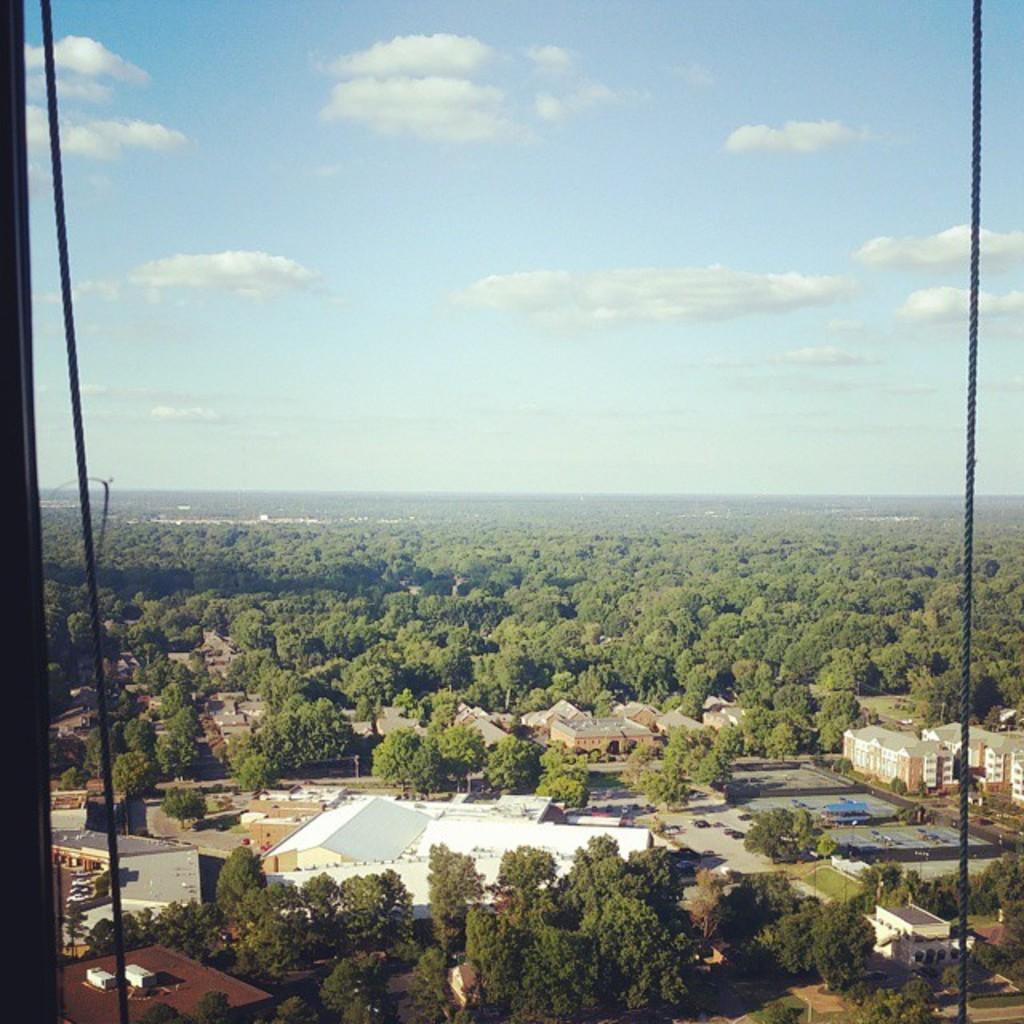What type of objects can be seen in the image? There are ropes, houses, trees, and other objects in the image. Can you describe the natural elements in the image? There are trees and clouds in the sky in the image. How many houses are visible in the image? There are houses in the image, but the exact number is not specified. What type of duck can be seen swimming in the river in the image? There is no river or duck present in the image. What type of fact can be learned from the image? The provided facts do not mention any specific fact that can be learned from the image. 